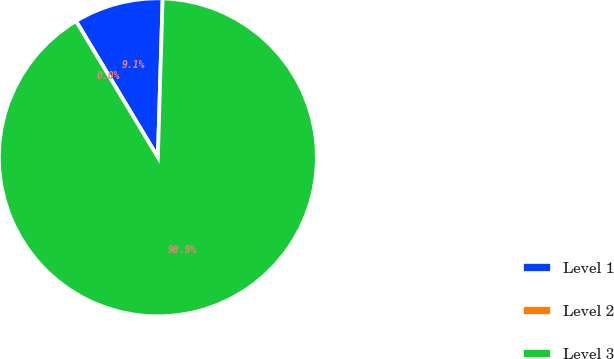Convert chart to OTSL. <chart><loc_0><loc_0><loc_500><loc_500><pie_chart><fcel>Level 1<fcel>Level 2<fcel>Level 3<nl><fcel>9.09%<fcel>0.0%<fcel>90.9%<nl></chart> 